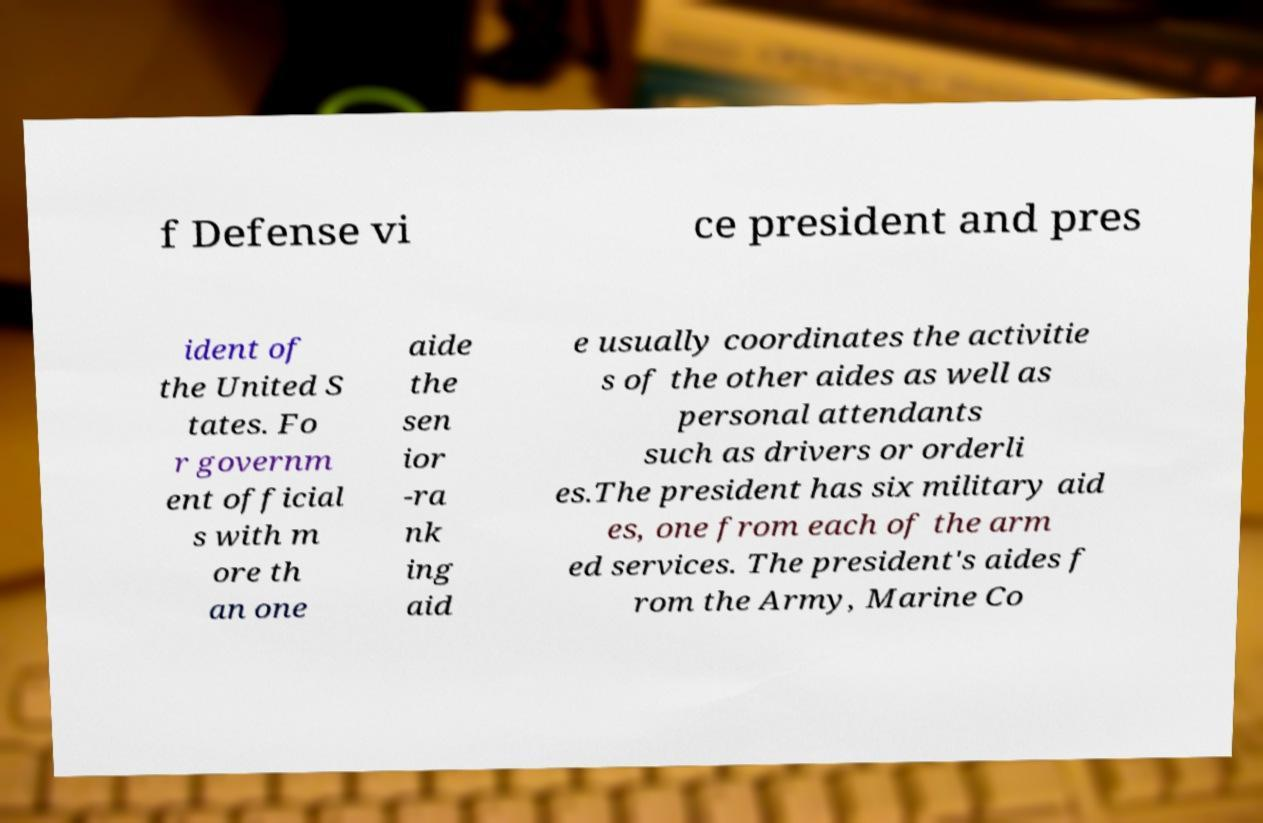Could you extract and type out the text from this image? f Defense vi ce president and pres ident of the United S tates. Fo r governm ent official s with m ore th an one aide the sen ior -ra nk ing aid e usually coordinates the activitie s of the other aides as well as personal attendants such as drivers or orderli es.The president has six military aid es, one from each of the arm ed services. The president's aides f rom the Army, Marine Co 